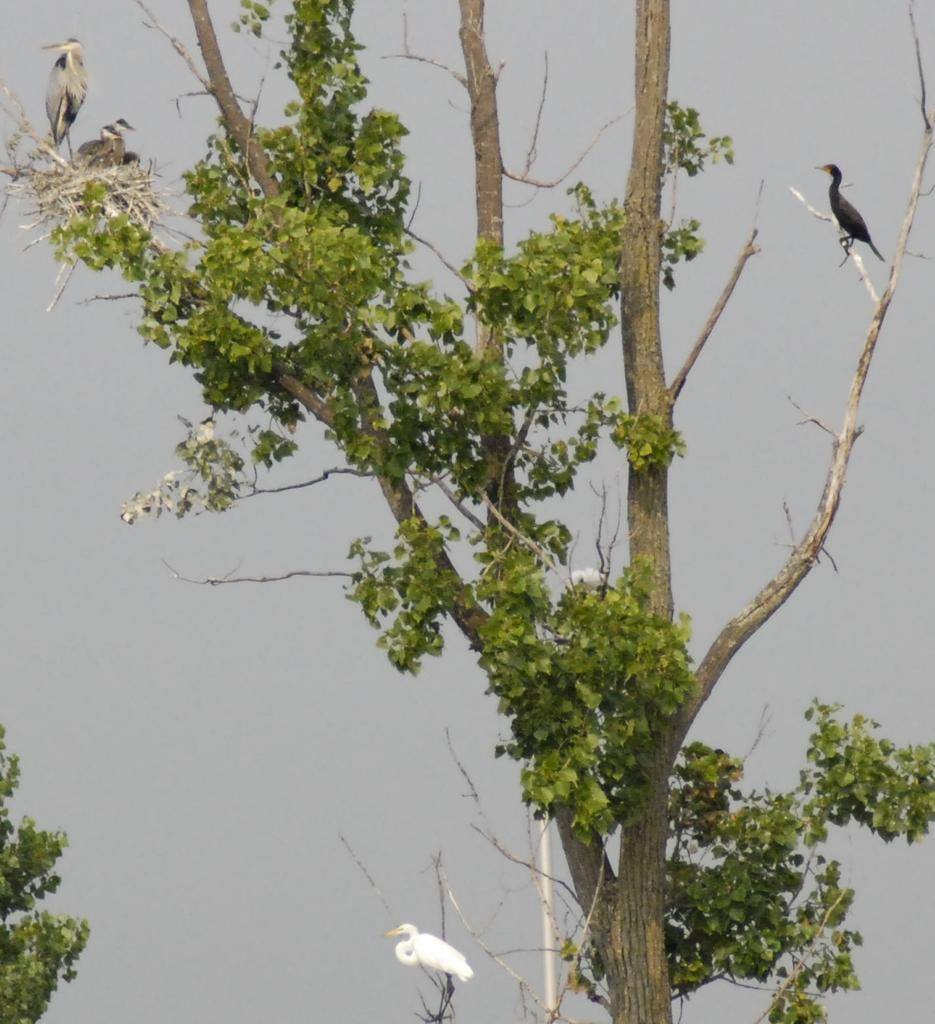What is the main object in the image? There is a tree in the image. What is located on the tree? There is a nest on the branches of the tree. What type of animals can be seen on the tree? There are birds standing on the branches. What color is the background of the image? The background of the image is grey. Where is the wax parcel hidden in the image? There is no wax parcel present in the image. Can you describe the garden in the image? The image does not show a garden; it features a tree with a nest and birds. 